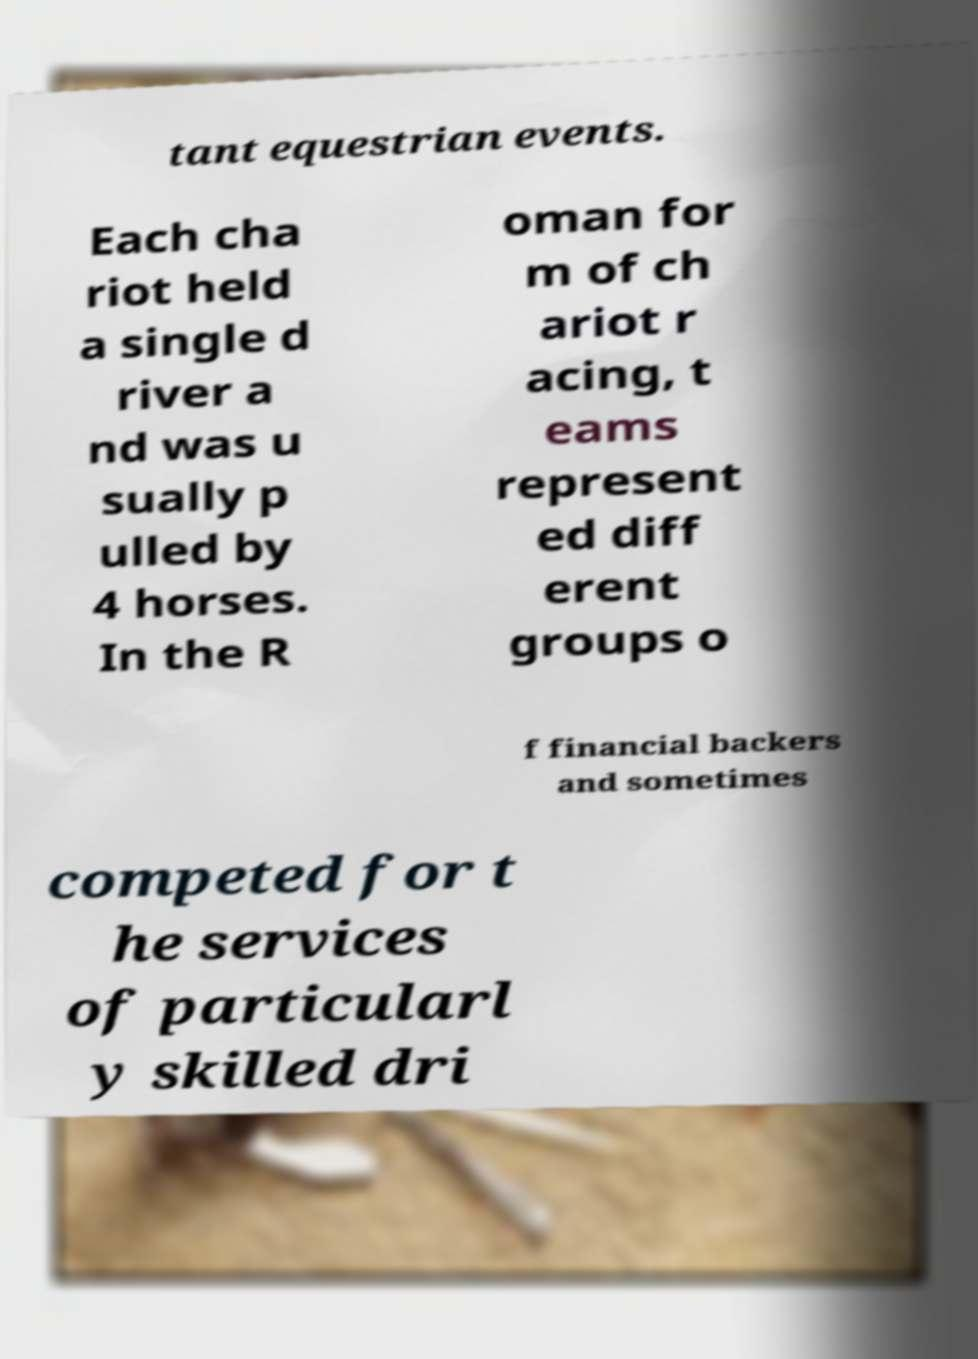For documentation purposes, I need the text within this image transcribed. Could you provide that? tant equestrian events. Each cha riot held a single d river a nd was u sually p ulled by 4 horses. In the R oman for m of ch ariot r acing, t eams represent ed diff erent groups o f financial backers and sometimes competed for t he services of particularl y skilled dri 